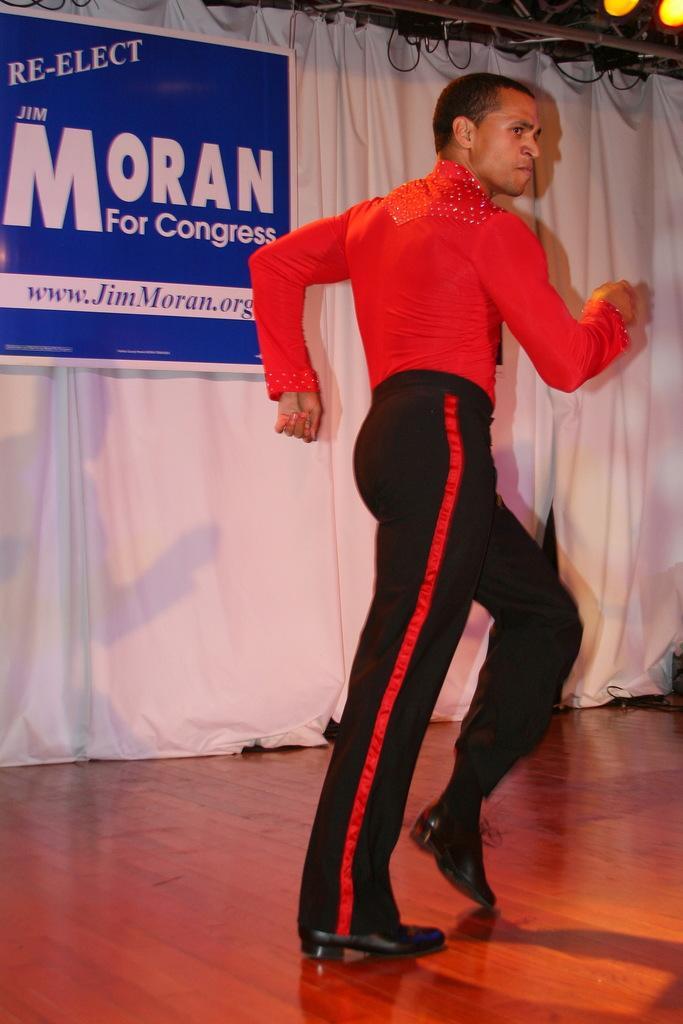In one or two sentences, can you explain what this image depicts? In this image there is a person dancing on the stage behind him there is a curtain and banner on it. 